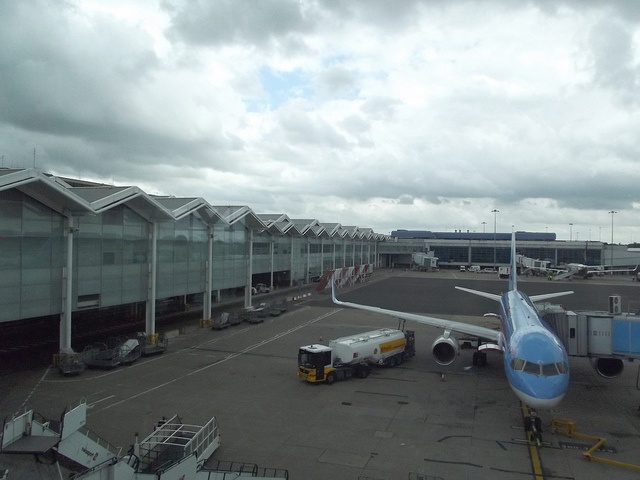Describe the objects in this image and their specific colors. I can see airplane in darkgray and gray tones, truck in darkgray, black, and gray tones, and airplane in darkgray, gray, and black tones in this image. 